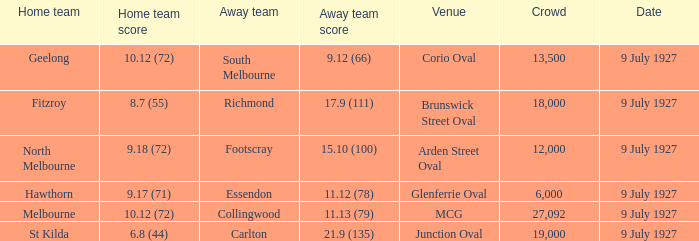Would you mind parsing the complete table? {'header': ['Home team', 'Home team score', 'Away team', 'Away team score', 'Venue', 'Crowd', 'Date'], 'rows': [['Geelong', '10.12 (72)', 'South Melbourne', '9.12 (66)', 'Corio Oval', '13,500', '9 July 1927'], ['Fitzroy', '8.7 (55)', 'Richmond', '17.9 (111)', 'Brunswick Street Oval', '18,000', '9 July 1927'], ['North Melbourne', '9.18 (72)', 'Footscray', '15.10 (100)', 'Arden Street Oval', '12,000', '9 July 1927'], ['Hawthorn', '9.17 (71)', 'Essendon', '11.12 (78)', 'Glenferrie Oval', '6,000', '9 July 1927'], ['Melbourne', '10.12 (72)', 'Collingwood', '11.13 (79)', 'MCG', '27,092', '9 July 1927'], ['St Kilda', '6.8 (44)', 'Carlton', '21.9 (135)', 'Junction Oval', '19,000', '9 July 1927']]} How large was the crowd at Brunswick Street Oval? 18000.0. 